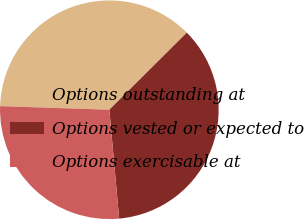Convert chart. <chart><loc_0><loc_0><loc_500><loc_500><pie_chart><fcel>Options outstanding at<fcel>Options vested or expected to<fcel>Options exercisable at<nl><fcel>37.01%<fcel>36.03%<fcel>26.96%<nl></chart> 